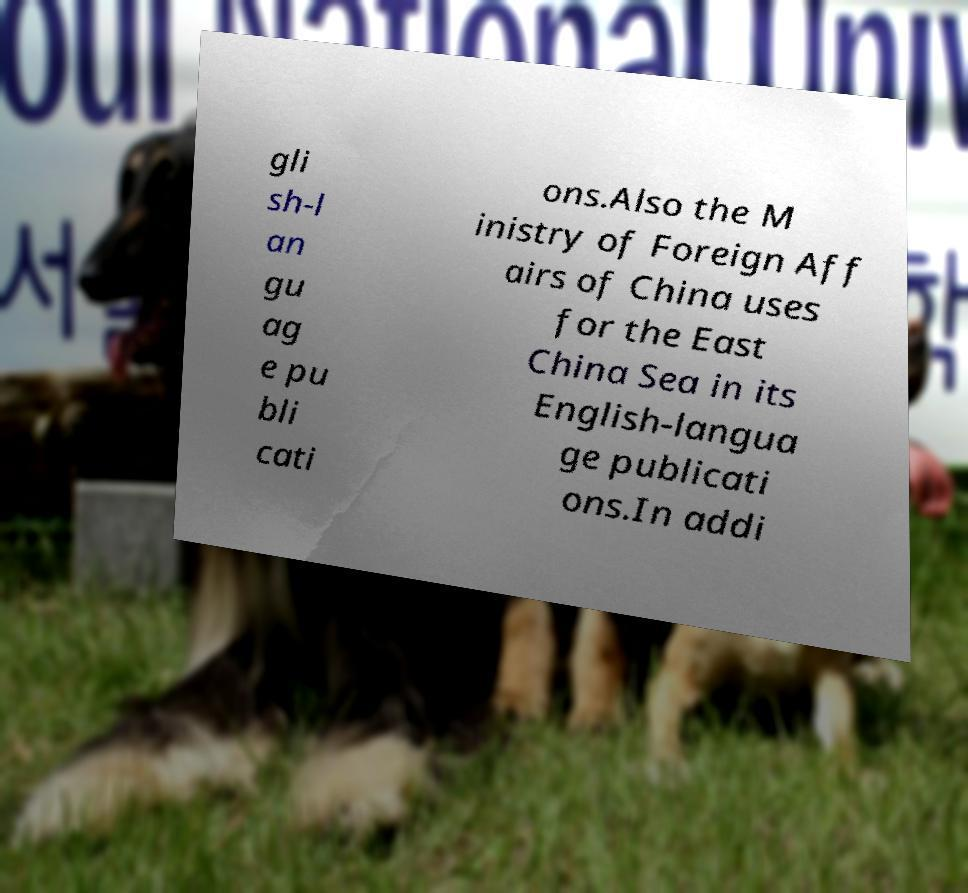Could you assist in decoding the text presented in this image and type it out clearly? gli sh-l an gu ag e pu bli cati ons.Also the M inistry of Foreign Aff airs of China uses for the East China Sea in its English-langua ge publicati ons.In addi 